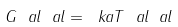<formula> <loc_0><loc_0><loc_500><loc_500>G ^ { \ } a l _ { \ } a l = \ k a T ^ { \ } a l _ { \ } a l</formula> 